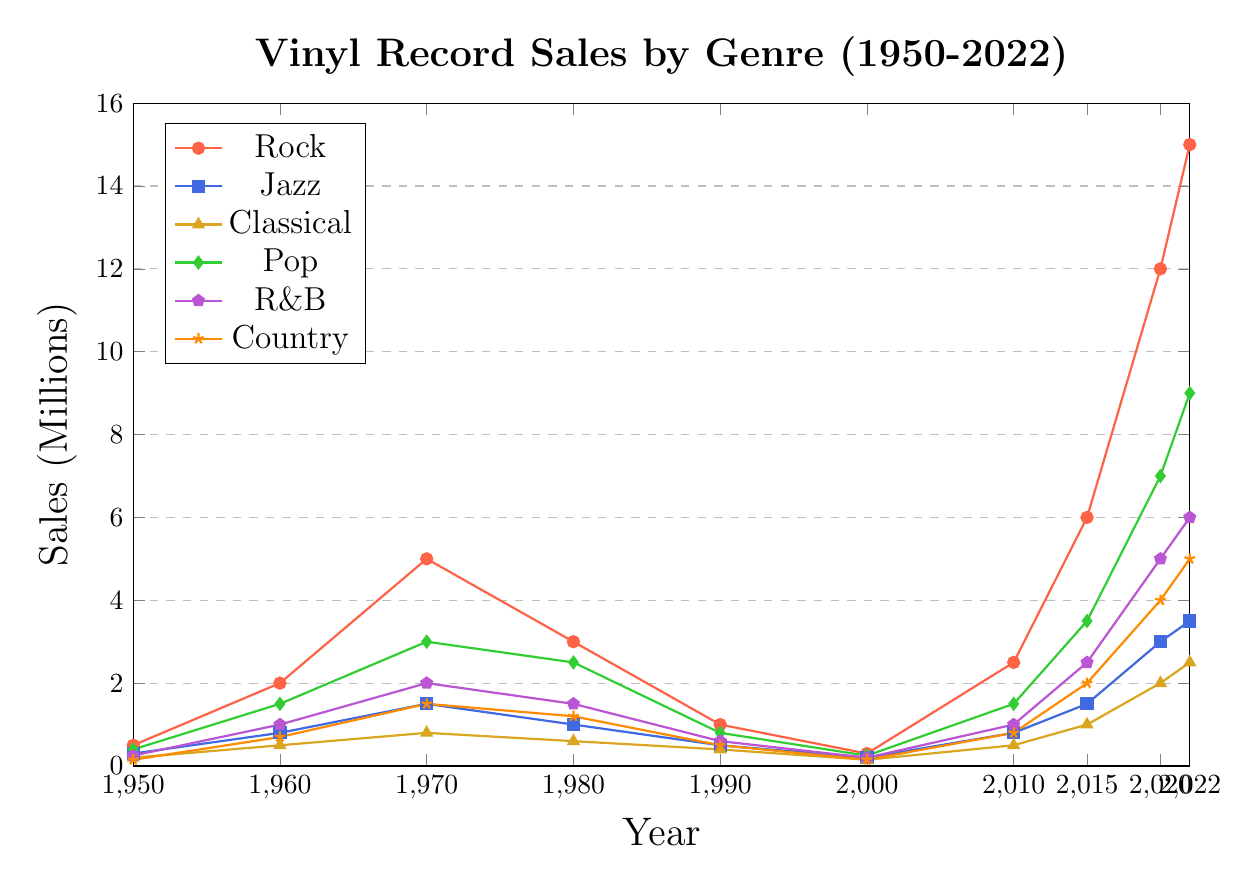What's the peak year for Rock vinyl sales? The peak year for Rock can be identified by finding the year with the highest point for the Rock line. The highest point on the Rock line is at 2022.
Answer: 2022 How much did Jazz vinyl sales increase from 1950 to 2022? Calculate the difference between Jazz vinyl sales in 2022 and 1950 by subtracting 0.3 million (1950) from 3.5 million (2022).
Answer: 3.2 million Which genre had the lowest sales in 1980? Compare the heights of each genre's line for the year 1980. Classical has the lowest height at 0.6 million.
Answer: Classical What was the average sales of Country vinyls in 2000, 2010, and 2015? Sum the sales for Country in these years (0.15 + 0.8 + 2) and then divide by 3 to get the average.
Answer: 0.983 million Did Rock or Pop have higher sales in 2020? Compare the heights of the Rock and Pop lines for 2020. Rock is at 12 million while Pop is at 7 million.
Answer: Rock By how much did Pop sales decrease from 1970 to 1990? Subtract the 1990 value (0.8 million) from the 1970 value (3 million).
Answer: 2.2 million Which genre had the most steady sales trend (least variance) between 1950 and 2000? Identify the genre whose line shows the least change in height over the given period. This is Classical.
Answer: Classical What is the total sales for all genres in 1960? Sum the sales for all genres in 1960 (2 + 0.8 + 0.5 + 1.5 + 1 + 0.7).
Answer: 6.5 million How does R&B sales growth from 2010 to 2022 compare to the growth from 1960 to 1970? Subtract the 1960 value (1 million) from the 1970 value (2 million) and the 2010 value (1 million) from the 2022 value (6 million). Compare the differences. The growth from 2010 to 2022 is 5 million, while the growth from 1960 to 1970 is 1 million.
Answer: Growth from 2010 to 2022 is higher Which genre showed a significant rebound in sales after 2000? Look for genres with notable rises after the year 2000. Both Rock and Pop showed significant rebounds.
Answer: Rock and Pop 